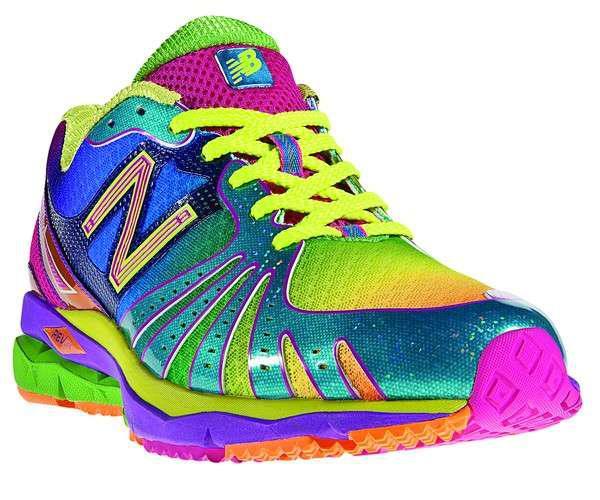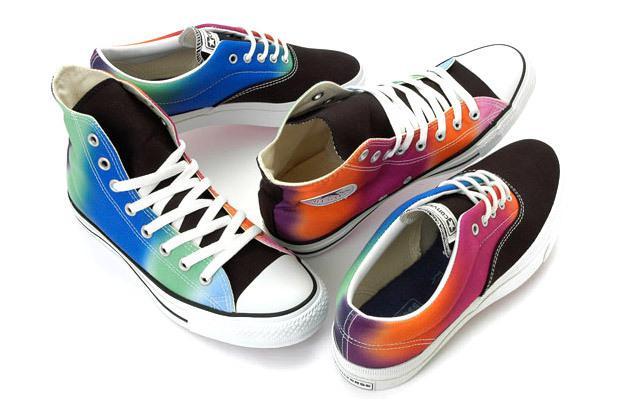The first image is the image on the left, the second image is the image on the right. Analyze the images presented: Is the assertion "One image shows only one colorful shoe with matching laces." valid? Answer yes or no. Yes. The first image is the image on the left, the second image is the image on the right. Examine the images to the left and right. Is the description "There is exactly one shoe in the image on the left." accurate? Answer yes or no. Yes. 